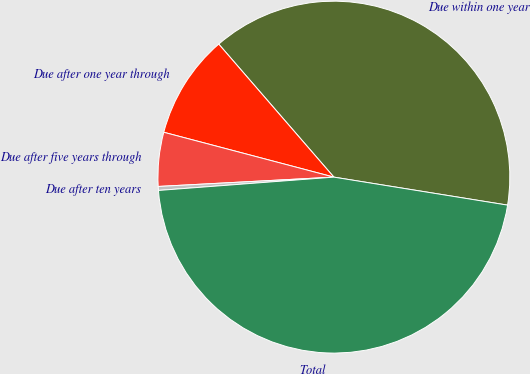<chart> <loc_0><loc_0><loc_500><loc_500><pie_chart><fcel>Due within one year<fcel>Due after one year through<fcel>Due after five years through<fcel>Due after ten years<fcel>Total<nl><fcel>38.9%<fcel>9.54%<fcel>4.95%<fcel>0.36%<fcel>46.25%<nl></chart> 